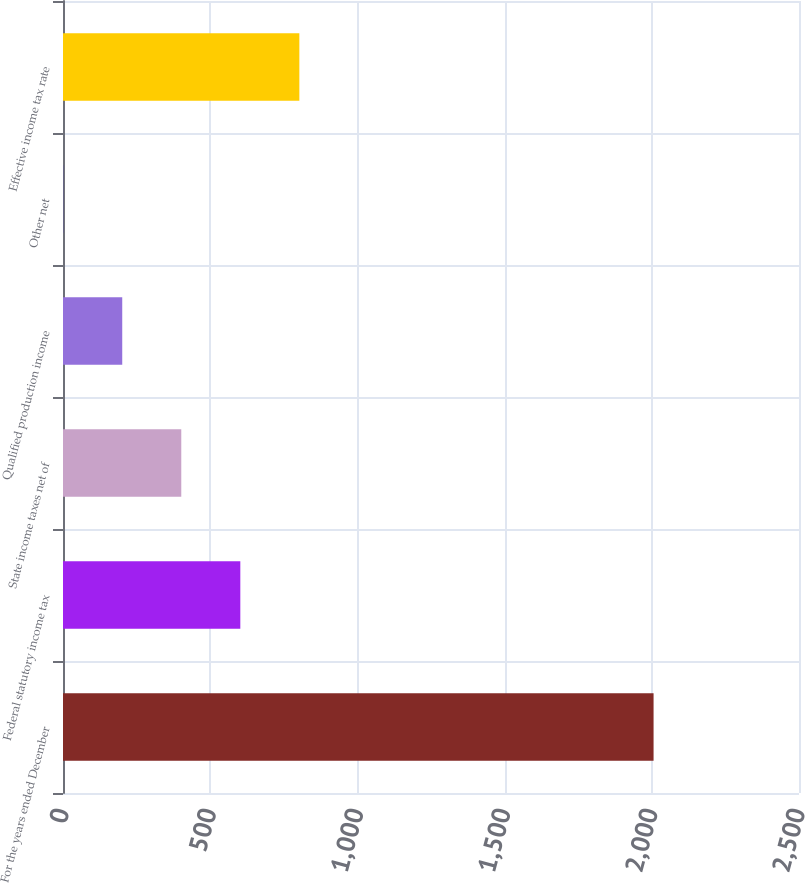<chart> <loc_0><loc_0><loc_500><loc_500><bar_chart><fcel>For the years ended December<fcel>Federal statutory income tax<fcel>State income taxes net of<fcel>Qualified production income<fcel>Other net<fcel>Effective income tax rate<nl><fcel>2006<fcel>602.29<fcel>401.76<fcel>201.23<fcel>0.7<fcel>802.82<nl></chart> 